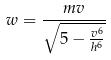Convert formula to latex. <formula><loc_0><loc_0><loc_500><loc_500>w = \frac { m v } { \sqrt { 5 - \frac { v ^ { 6 } } { h ^ { 6 } } } }</formula> 